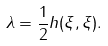<formula> <loc_0><loc_0><loc_500><loc_500>\lambda = \frac { 1 } { 2 } h ( \xi , \xi ) .</formula> 